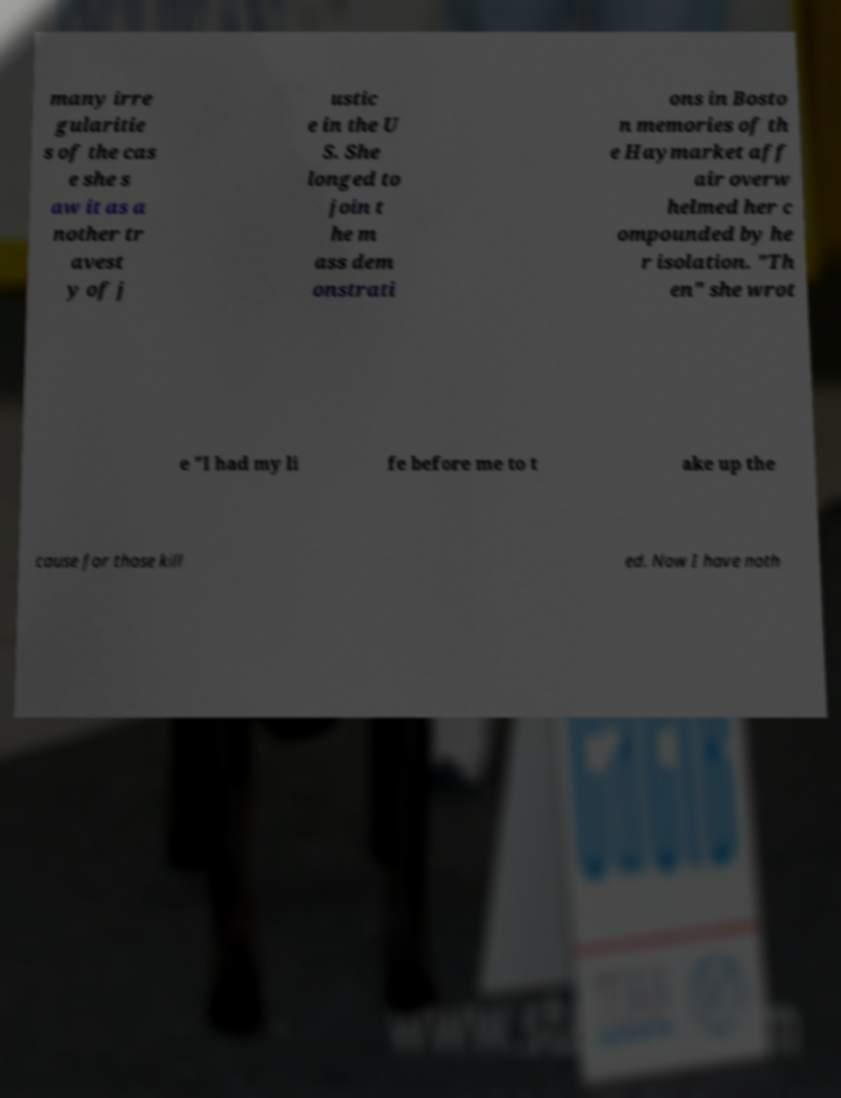Could you extract and type out the text from this image? many irre gularitie s of the cas e she s aw it as a nother tr avest y of j ustic e in the U S. She longed to join t he m ass dem onstrati ons in Bosto n memories of th e Haymarket aff air overw helmed her c ompounded by he r isolation. "Th en" she wrot e "I had my li fe before me to t ake up the cause for those kill ed. Now I have noth 